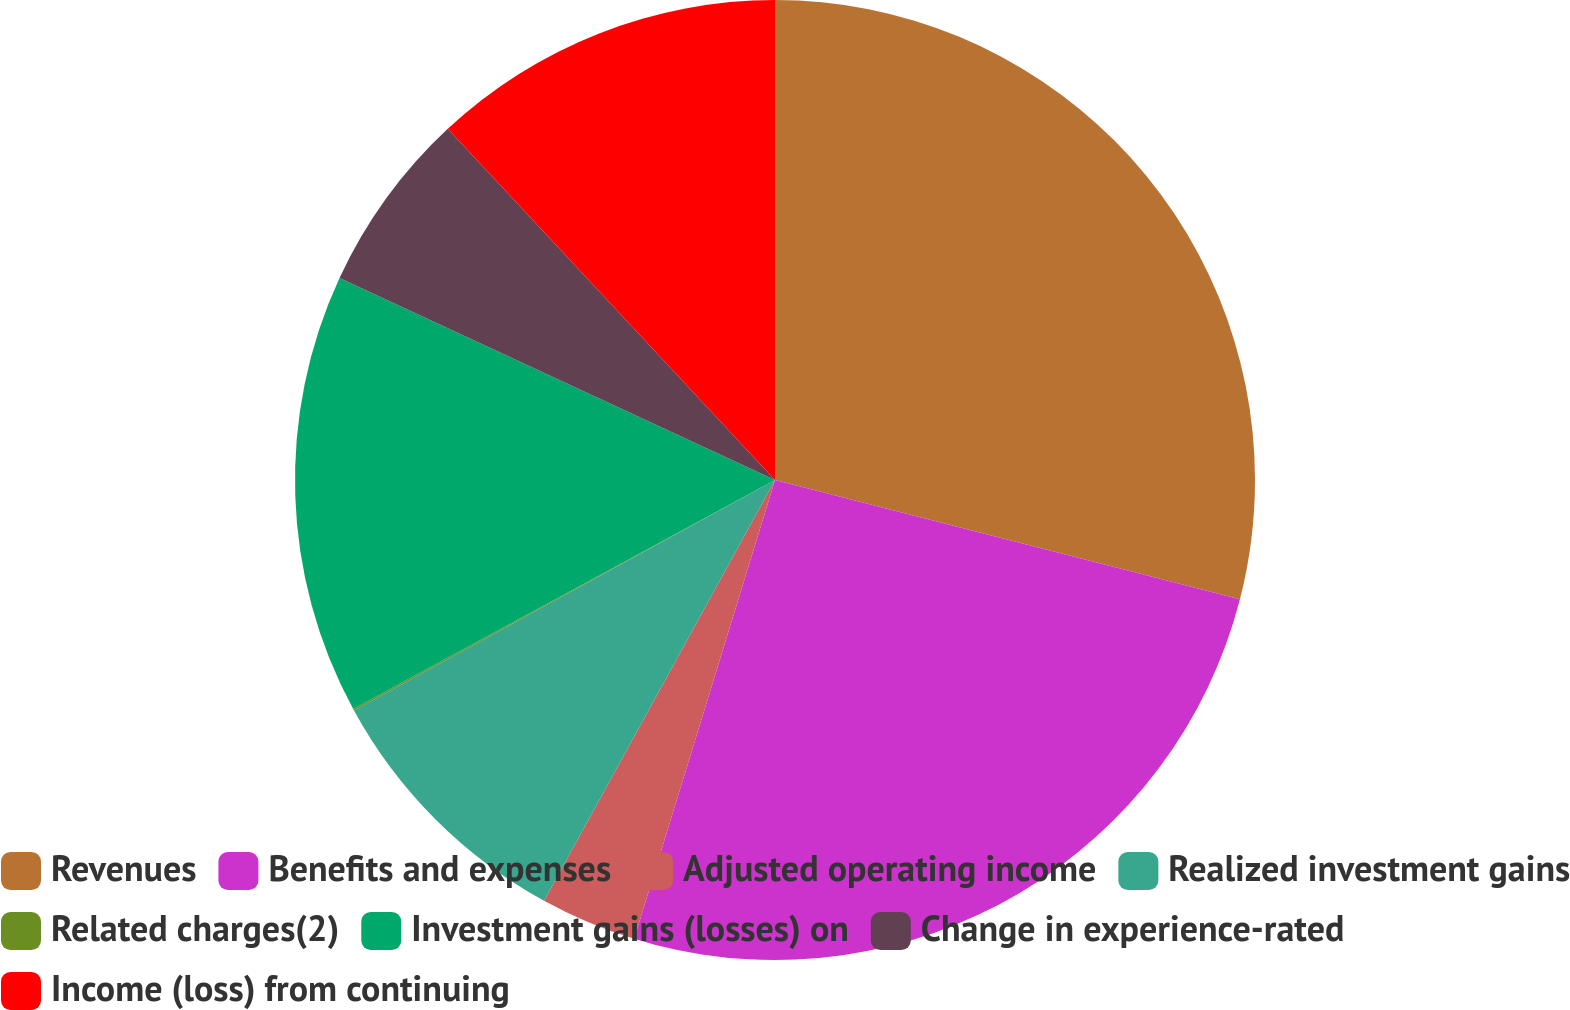Convert chart to OTSL. <chart><loc_0><loc_0><loc_500><loc_500><pie_chart><fcel>Revenues<fcel>Benefits and expenses<fcel>Adjusted operating income<fcel>Realized investment gains<fcel>Related charges(2)<fcel>Investment gains (losses) on<fcel>Change in experience-rated<fcel>Income (loss) from continuing<nl><fcel>29.0%<fcel>25.74%<fcel>3.25%<fcel>9.04%<fcel>0.05%<fcel>14.83%<fcel>6.15%<fcel>11.94%<nl></chart> 